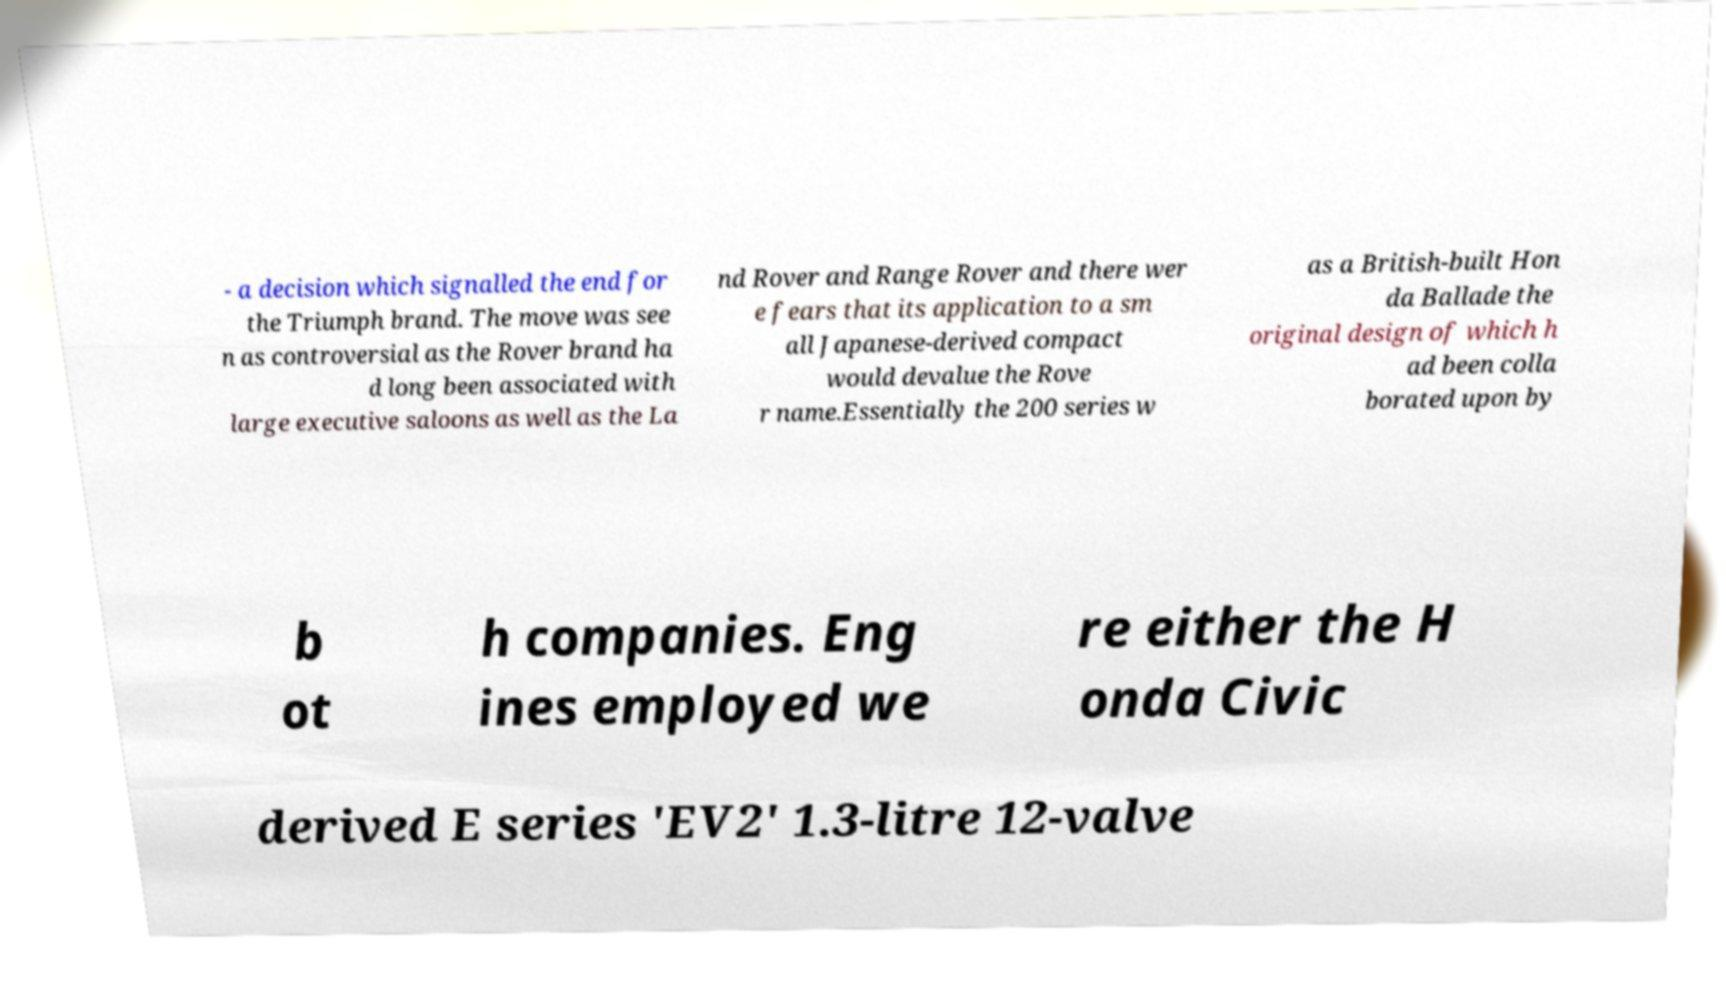Can you read and provide the text displayed in the image?This photo seems to have some interesting text. Can you extract and type it out for me? - a decision which signalled the end for the Triumph brand. The move was see n as controversial as the Rover brand ha d long been associated with large executive saloons as well as the La nd Rover and Range Rover and there wer e fears that its application to a sm all Japanese-derived compact would devalue the Rove r name.Essentially the 200 series w as a British-built Hon da Ballade the original design of which h ad been colla borated upon by b ot h companies. Eng ines employed we re either the H onda Civic derived E series 'EV2' 1.3-litre 12-valve 